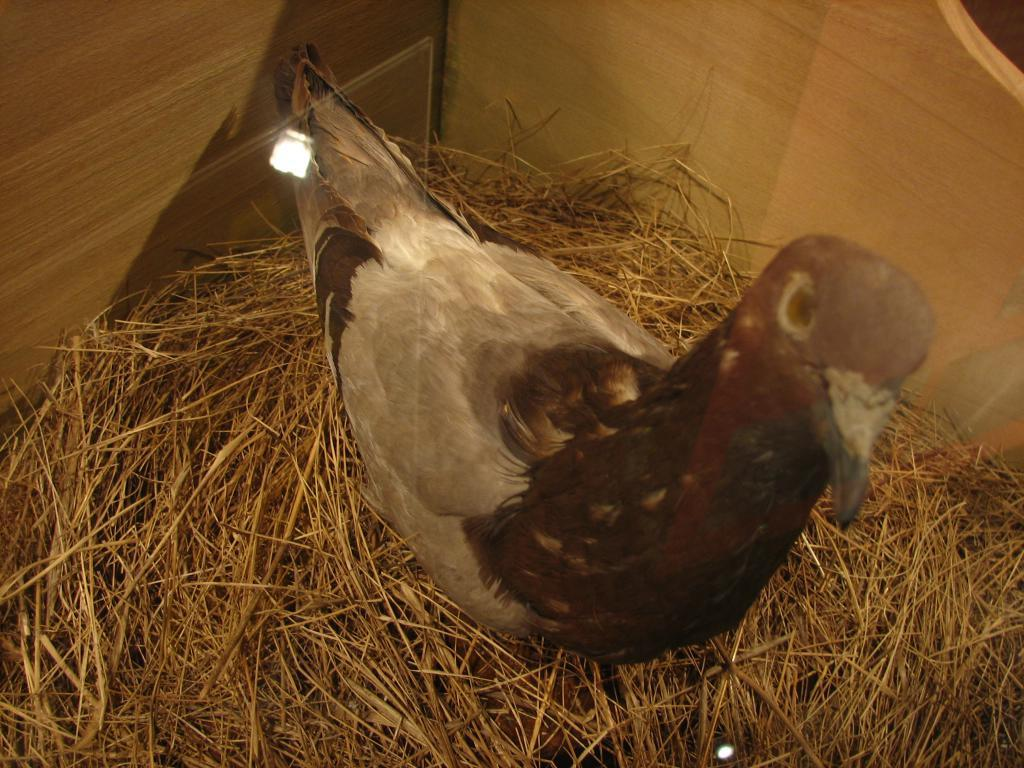What is the main subject in the center of the image? There is a pigeon in the center of the image. What type of vegetation is present at the bottom of the image? There is dry grass at the bottom of the image. What kind of object can be seen in the background of the image? There is a wooden box in the background of the image. Where is the bat hanging in the image? There is no bat present in the image. What type of sea creature can be seen swimming in the image? There is no sea or sea creature present in the image. 